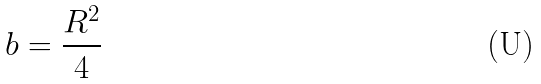<formula> <loc_0><loc_0><loc_500><loc_500>b = \frac { R ^ { 2 } } { 4 }</formula> 